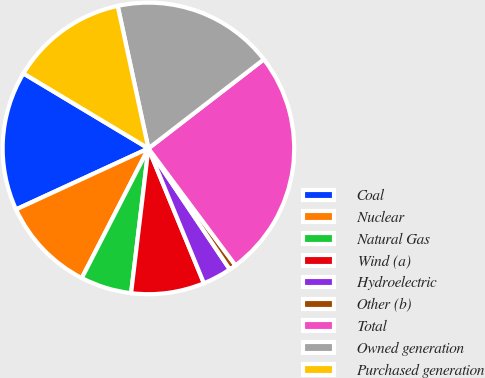Convert chart to OTSL. <chart><loc_0><loc_0><loc_500><loc_500><pie_chart><fcel>Coal<fcel>Nuclear<fcel>Natural Gas<fcel>Wind (a)<fcel>Hydroelectric<fcel>Other (b)<fcel>Total<fcel>Owned generation<fcel>Purchased generation<nl><fcel>15.47%<fcel>10.57%<fcel>5.66%<fcel>8.11%<fcel>3.21%<fcel>0.76%<fcel>25.28%<fcel>17.92%<fcel>13.02%<nl></chart> 